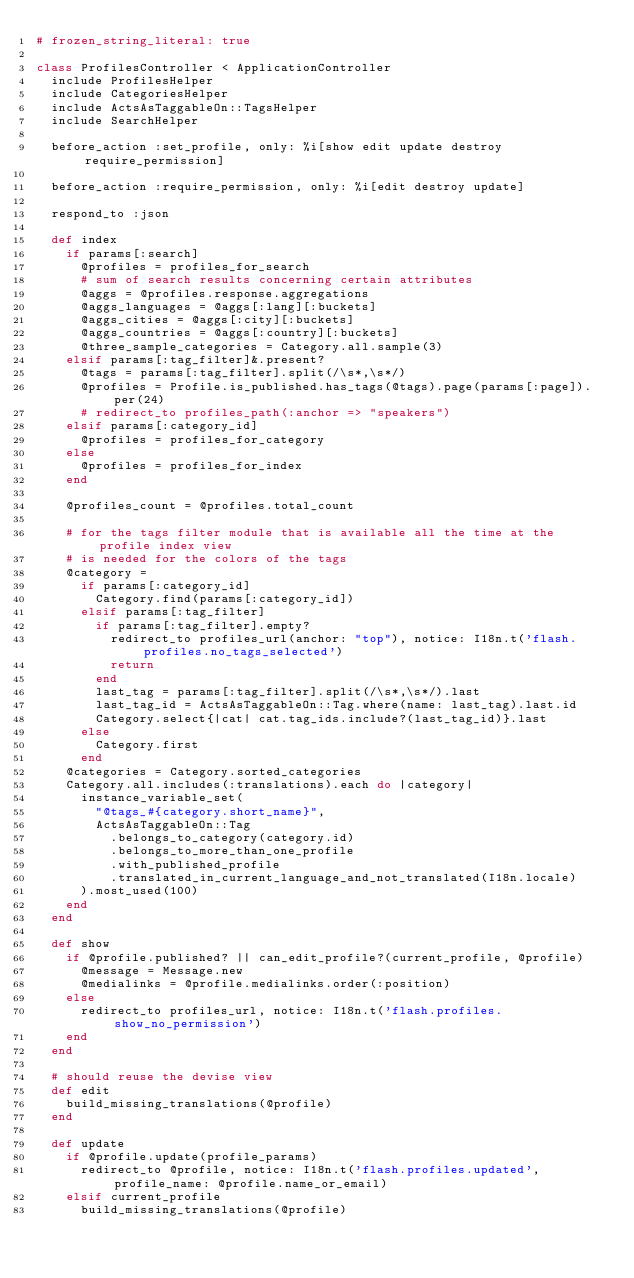<code> <loc_0><loc_0><loc_500><loc_500><_Ruby_># frozen_string_literal: true

class ProfilesController < ApplicationController
  include ProfilesHelper
  include CategoriesHelper
  include ActsAsTaggableOn::TagsHelper
  include SearchHelper

  before_action :set_profile, only: %i[show edit update destroy require_permission]

  before_action :require_permission, only: %i[edit destroy update]

  respond_to :json

  def index
    if params[:search]
      @profiles = profiles_for_search
      # sum of search results concerning certain attributes
      @aggs = @profiles.response.aggregations
      @aggs_languages = @aggs[:lang][:buckets]
      @aggs_cities = @aggs[:city][:buckets]
      @aggs_countries = @aggs[:country][:buckets]
      @three_sample_categories = Category.all.sample(3)
    elsif params[:tag_filter]&.present?
      @tags = params[:tag_filter].split(/\s*,\s*/)
      @profiles = Profile.is_published.has_tags(@tags).page(params[:page]).per(24)
      # redirect_to profiles_path(:anchor => "speakers")
    elsif params[:category_id]
      @profiles = profiles_for_category
    else
      @profiles = profiles_for_index
    end

    @profiles_count = @profiles.total_count

    # for the tags filter module that is available all the time at the profile index view
    # is needed for the colors of the tags
    @category = 
      if params[:category_id] 
        Category.find(params[:category_id]) 
      elsif params[:tag_filter]
        if params[:tag_filter].empty?
          redirect_to profiles_url(anchor: "top"), notice: I18n.t('flash.profiles.no_tags_selected') 
          return
        end
        last_tag = params[:tag_filter].split(/\s*,\s*/).last
        last_tag_id = ActsAsTaggableOn::Tag.where(name: last_tag).last.id
        Category.select{|cat| cat.tag_ids.include?(last_tag_id)}.last
      else    
        Category.first
      end
    @categories = Category.sorted_categories
    Category.all.includes(:translations).each do |category|
      instance_variable_set(
        "@tags_#{category.short_name}",
        ActsAsTaggableOn::Tag
          .belongs_to_category(category.id)
          .belongs_to_more_than_one_profile
          .with_published_profile
          .translated_in_current_language_and_not_translated(I18n.locale)
      ).most_used(100)
    end
  end

  def show
    if @profile.published? || can_edit_profile?(current_profile, @profile)
      @message = Message.new
      @medialinks = @profile.medialinks.order(:position)
    else
      redirect_to profiles_url, notice: I18n.t('flash.profiles.show_no_permission')
    end
  end

  # should reuse the devise view
  def edit
    build_missing_translations(@profile)
  end

  def update
    if @profile.update(profile_params)
      redirect_to @profile, notice: I18n.t('flash.profiles.updated', profile_name: @profile.name_or_email)
    elsif current_profile
      build_missing_translations(@profile)</code> 